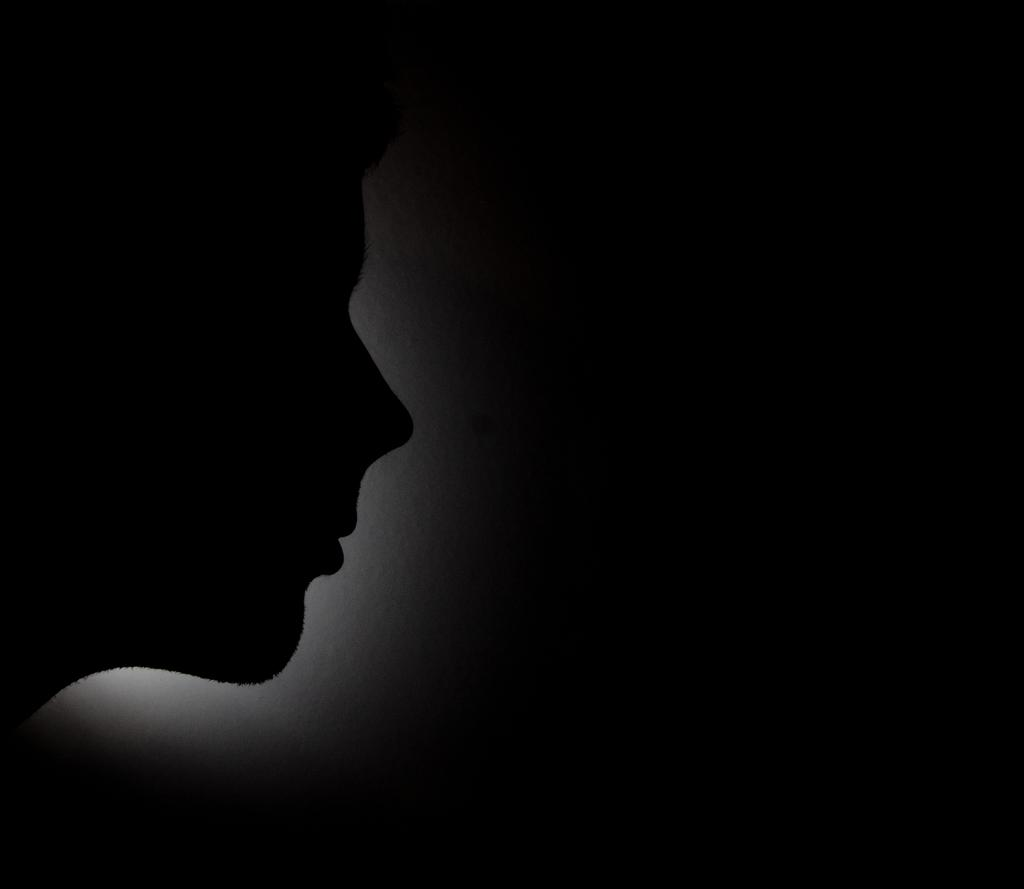What is the main subject of the image? There is a person in the image. Can you describe the lighting in the image? There is a white color light behind the person. How would you describe the background of the image? The background of the image is dark. What type of plantation can be seen in the background of the image? There is no plantation present in the image; the background is dark. How many men are visible in the image? The image only features one person, not multiple men. 